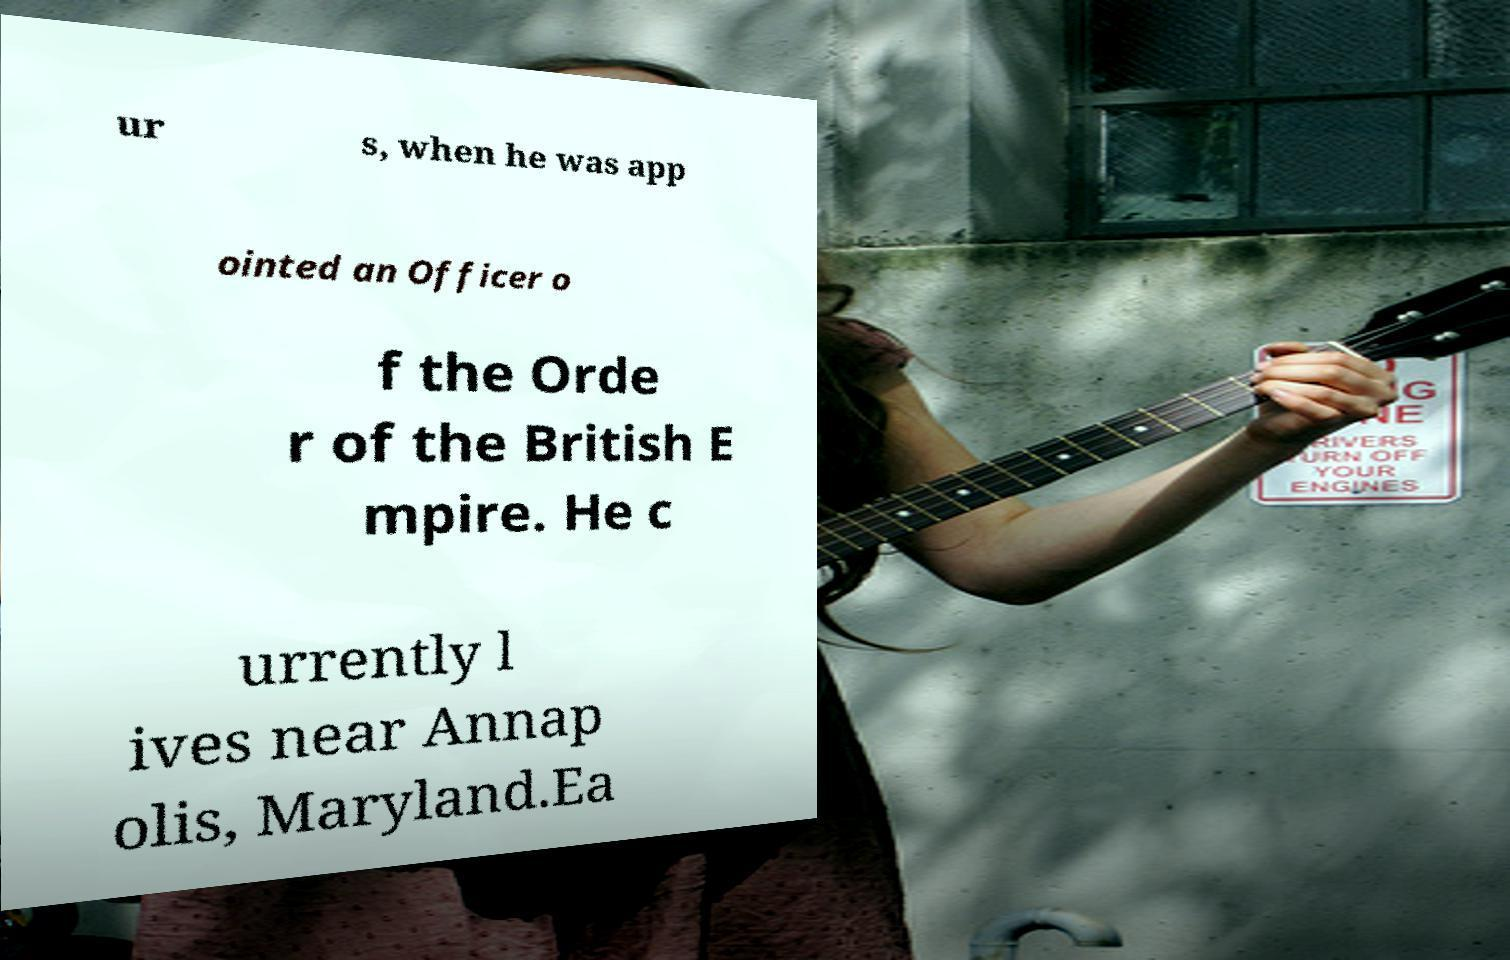Please read and relay the text visible in this image. What does it say? ur s, when he was app ointed an Officer o f the Orde r of the British E mpire. He c urrently l ives near Annap olis, Maryland.Ea 